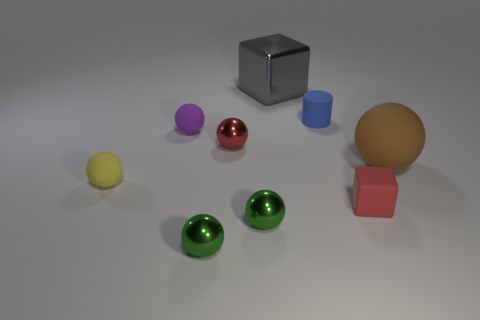What is the tiny cube made of?
Your response must be concise. Rubber. There is a tiny shiny ball behind the small yellow sphere; does it have the same color as the small matte cube?
Provide a short and direct response. Yes. There is a red thing that is right of the tiny object that is behind the small rubber ball to the right of the small yellow matte object; what is its material?
Provide a short and direct response. Rubber. There is a cube on the right side of the shiny block; is its color the same as the metal sphere that is behind the big matte thing?
Provide a succinct answer. Yes. There is a small purple object; is it the same shape as the metallic object on the left side of the small red shiny ball?
Ensure brevity in your answer.  Yes. What is the shape of the thing that is the same color as the tiny rubber cube?
Your answer should be compact. Sphere. What number of big gray cubes are on the right side of the green shiny thing left of the red object to the left of the rubber block?
Make the answer very short. 1. There is a rubber thing on the left side of the tiny rubber ball on the right side of the yellow matte object; what size is it?
Provide a succinct answer. Small. What size is the red sphere that is made of the same material as the big gray thing?
Make the answer very short. Small. The shiny object that is both behind the tiny red rubber block and in front of the small rubber cylinder has what shape?
Offer a very short reply. Sphere. 